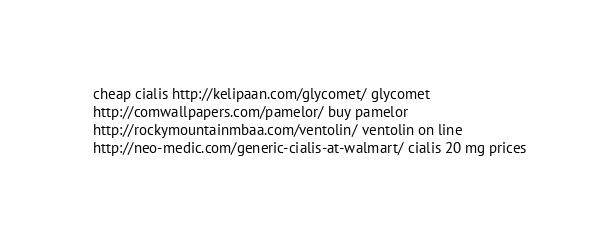Convert code to text. <code><loc_0><loc_0><loc_500><loc_500><_YAML_>  cheap cialis http://kelipaan.com/glycomet/ glycomet
  http://comwallpapers.com/pamelor/ buy pamelor
  http://rockymountainmbaa.com/ventolin/ ventolin on line
  http://neo-medic.com/generic-cialis-at-walmart/ cialis 20 mg prices</code> 